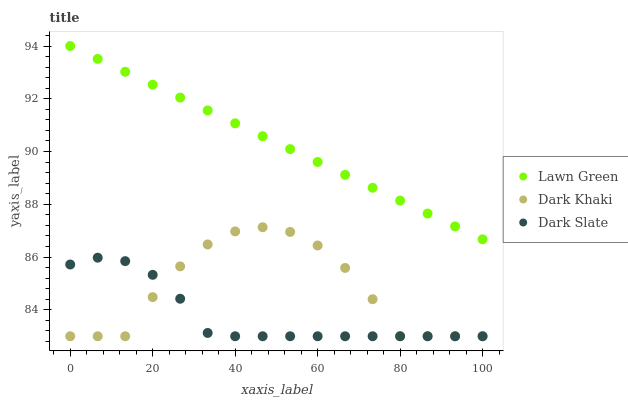Does Dark Slate have the minimum area under the curve?
Answer yes or no. Yes. Does Lawn Green have the maximum area under the curve?
Answer yes or no. Yes. Does Lawn Green have the minimum area under the curve?
Answer yes or no. No. Does Dark Slate have the maximum area under the curve?
Answer yes or no. No. Is Lawn Green the smoothest?
Answer yes or no. Yes. Is Dark Khaki the roughest?
Answer yes or no. Yes. Is Dark Slate the smoothest?
Answer yes or no. No. Is Dark Slate the roughest?
Answer yes or no. No. Does Dark Khaki have the lowest value?
Answer yes or no. Yes. Does Lawn Green have the lowest value?
Answer yes or no. No. Does Lawn Green have the highest value?
Answer yes or no. Yes. Does Dark Slate have the highest value?
Answer yes or no. No. Is Dark Khaki less than Lawn Green?
Answer yes or no. Yes. Is Lawn Green greater than Dark Slate?
Answer yes or no. Yes. Does Dark Khaki intersect Dark Slate?
Answer yes or no. Yes. Is Dark Khaki less than Dark Slate?
Answer yes or no. No. Is Dark Khaki greater than Dark Slate?
Answer yes or no. No. Does Dark Khaki intersect Lawn Green?
Answer yes or no. No. 